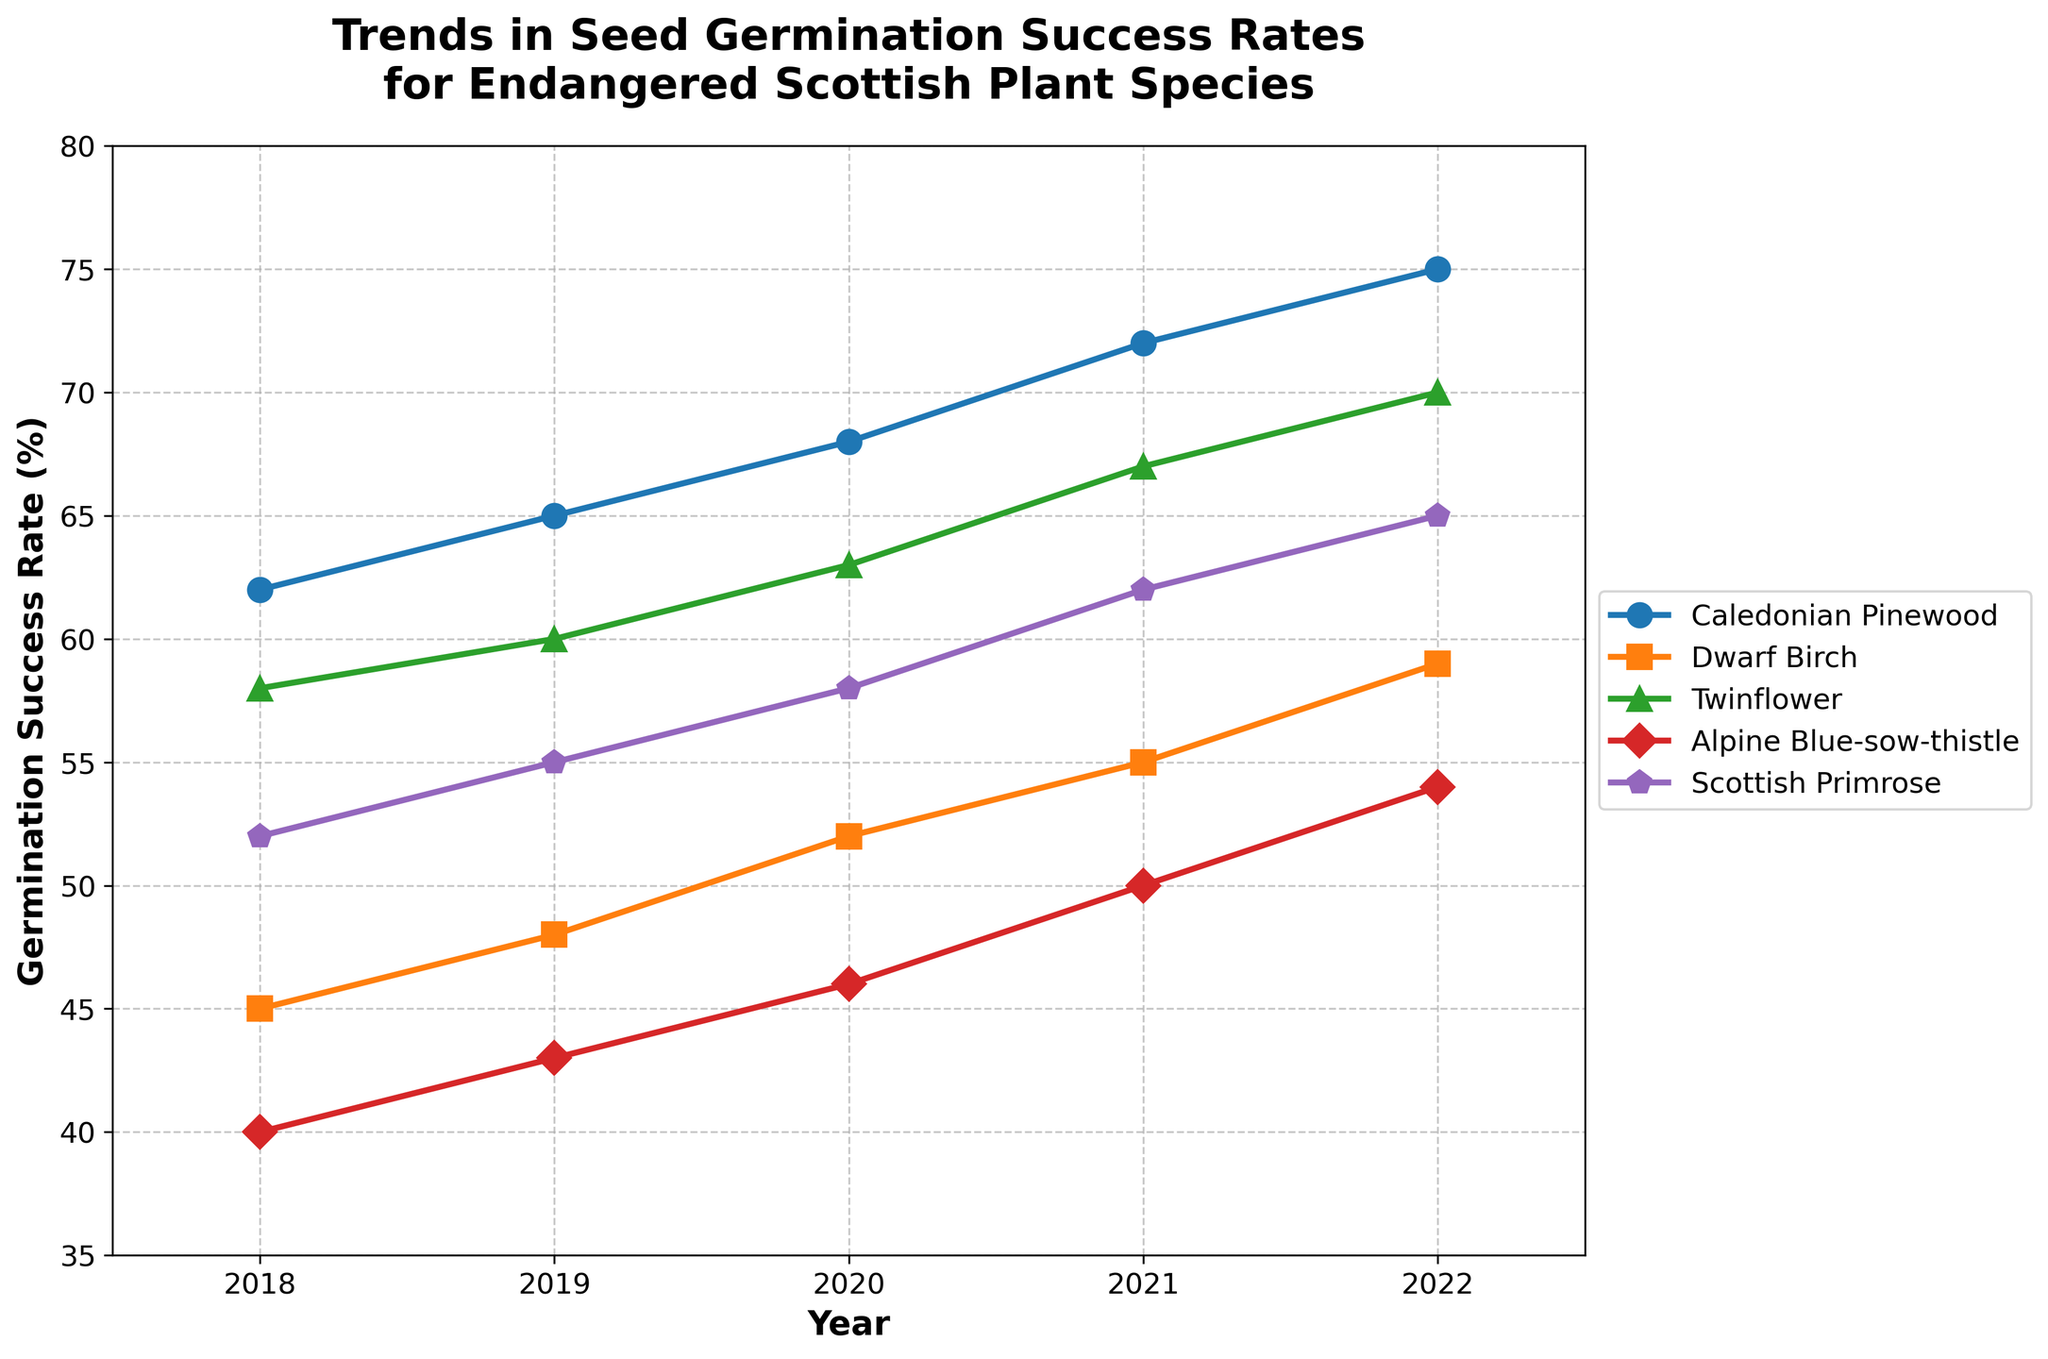Which species had the highest germination success rate in 2022? Look for the highest data point in the year 2022 and identify the corresponding species. The highest value is 75, which corresponds to Caledonian Pinewood.
Answer: Caledonian Pinewood What was the average germination success rate for the Scottish Primrose across the five years? Sum up the germination success rates for Scottish Primrose from 2018 to 2022 (52 + 55 + 58 + 62 + 65 = 292) and then divide by the number of years (5). 292 / 5 = 58.4
Answer: 58.4 Which year did the Twinflower show its greatest improvement in germination success rate compared to the previous year? Calculate the difference in germination success rates for Twinflower year by year and identify the year with the largest difference: 
2019-2018: 2, 2020-2019: 3, 2021-2020: 4, 2022-2021: 3. The greatest improvement was in 2021.
Answer: 2021 How does the germination success rate of Alpine Blue-sow-thistle in 2020 compare to that of Dwarf Birch in the same year? Compare the values in 2020 for both species. Alpine Blue-sow-thistle in 2020 is 46, and Dwarf Birch in 2020 is 52. Therefore, Dwarf Birch's rate is higher.
Answer: Dwarf Birch has a higher rate Which species shows the most consistent increase in germination success rate from 2018 to 2022? Analyze the trend lines for each species from 2018 to 2022 to see which one increases consistently without any decline in any year. All species show consistent increases, but Caledonian Pinewood has a particularly steady and regular increase.
Answer: Caledonian Pinewood What is the total increase in germination success rate for Dwarf Birch from 2018 to 2022? Subtract the germination success rate of Dwarf Birch in 2018 from its rate in 2022: 59 - 45 = 14.
Answer: 14 In which year did Dwarf Birch have a germination success rate greater than 50% for the first time within the given timeframe? Identify the first year in which the germination success rate for Dwarf Birch exceeds 50%. The value first exceeds 50 in 2020 (52).
Answer: 2020 Which year recorded the lowest germination success rate among all species? Look at the data points across all years and species to find the lowest value. The lowest germination success rate is 40 for Alpine Blue-sow-thistle in 2018.
Answer: 2018 What is the range of the germination success rates for Twinflower from 2018 to 2022? Determine the difference between the maximum and minimum germination success rates for Twinflower over the specified period: Maximum (70 in 2022) - Minimum (58 in 2018) = 12.
Answer: 12 